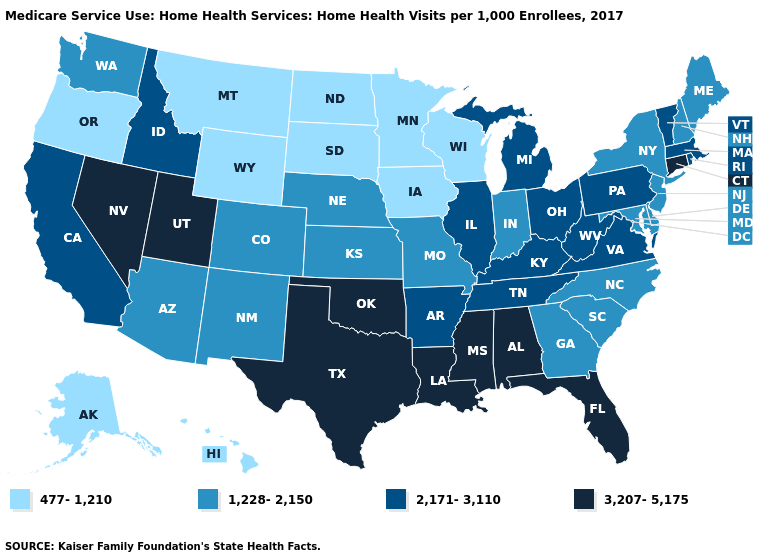Does the map have missing data?
Answer briefly. No. What is the highest value in the South ?
Give a very brief answer. 3,207-5,175. Does Wisconsin have a lower value than Alaska?
Answer briefly. No. What is the value of Pennsylvania?
Answer briefly. 2,171-3,110. What is the value of Kentucky?
Give a very brief answer. 2,171-3,110. Is the legend a continuous bar?
Answer briefly. No. Does Oregon have the highest value in the West?
Short answer required. No. Does West Virginia have the highest value in the South?
Write a very short answer. No. What is the lowest value in states that border Texas?
Short answer required. 1,228-2,150. What is the value of Wisconsin?
Concise answer only. 477-1,210. Among the states that border Tennessee , which have the lowest value?
Quick response, please. Georgia, Missouri, North Carolina. What is the lowest value in the West?
Give a very brief answer. 477-1,210. Is the legend a continuous bar?
Concise answer only. No. What is the lowest value in the USA?
Quick response, please. 477-1,210. 